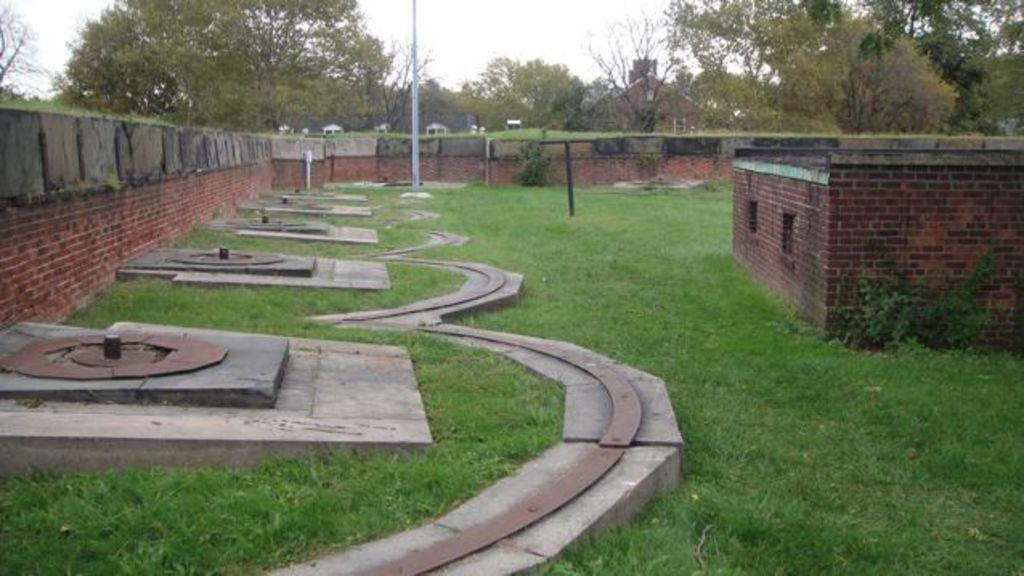Could you give a brief overview of what you see in this image? The image is taken in a garden. On the left there are some structures, wall and grass. On the right there is a building with brick walls. In the background there are trees, vehicles, pole, glass and building. 